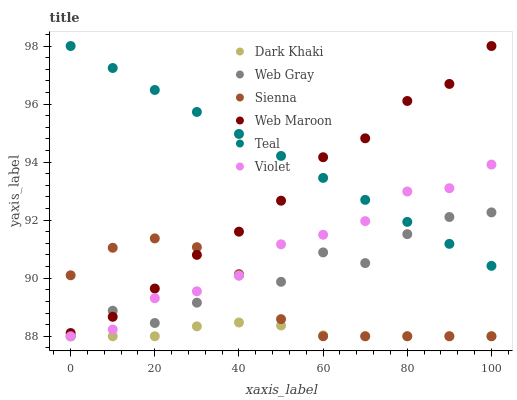Does Dark Khaki have the minimum area under the curve?
Answer yes or no. Yes. Does Teal have the maximum area under the curve?
Answer yes or no. Yes. Does Web Gray have the minimum area under the curve?
Answer yes or no. No. Does Web Gray have the maximum area under the curve?
Answer yes or no. No. Is Teal the smoothest?
Answer yes or no. Yes. Is Web Gray the roughest?
Answer yes or no. Yes. Is Web Maroon the smoothest?
Answer yes or no. No. Is Web Maroon the roughest?
Answer yes or no. No. Does Sienna have the lowest value?
Answer yes or no. Yes. Does Web Maroon have the lowest value?
Answer yes or no. No. Does Teal have the highest value?
Answer yes or no. Yes. Does Web Gray have the highest value?
Answer yes or no. No. Is Dark Khaki less than Teal?
Answer yes or no. Yes. Is Web Maroon greater than Violet?
Answer yes or no. Yes. Does Sienna intersect Violet?
Answer yes or no. Yes. Is Sienna less than Violet?
Answer yes or no. No. Is Sienna greater than Violet?
Answer yes or no. No. Does Dark Khaki intersect Teal?
Answer yes or no. No. 